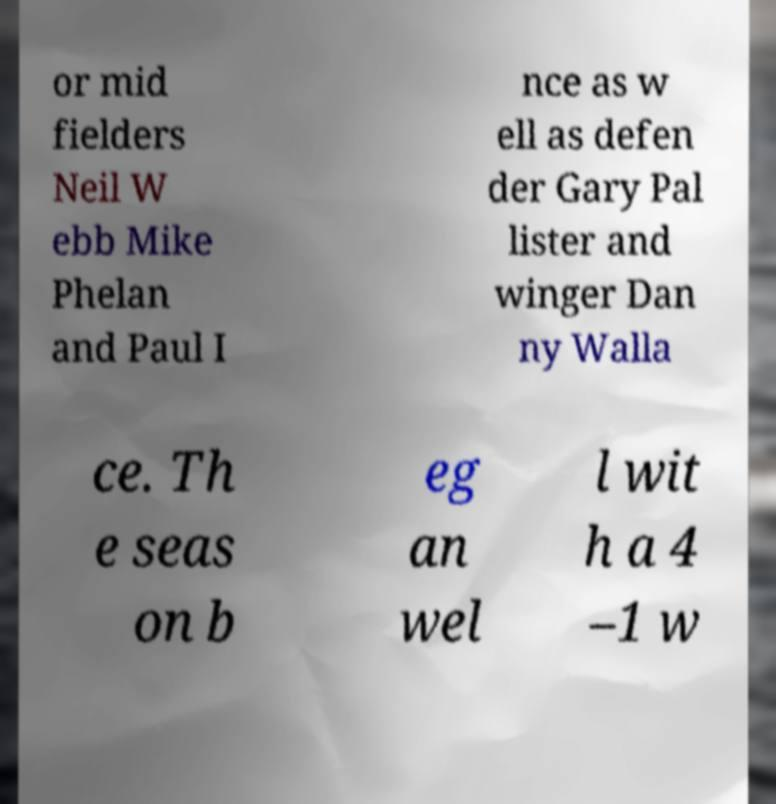Can you read and provide the text displayed in the image?This photo seems to have some interesting text. Can you extract and type it out for me? or mid fielders Neil W ebb Mike Phelan and Paul I nce as w ell as defen der Gary Pal lister and winger Dan ny Walla ce. Th e seas on b eg an wel l wit h a 4 –1 w 